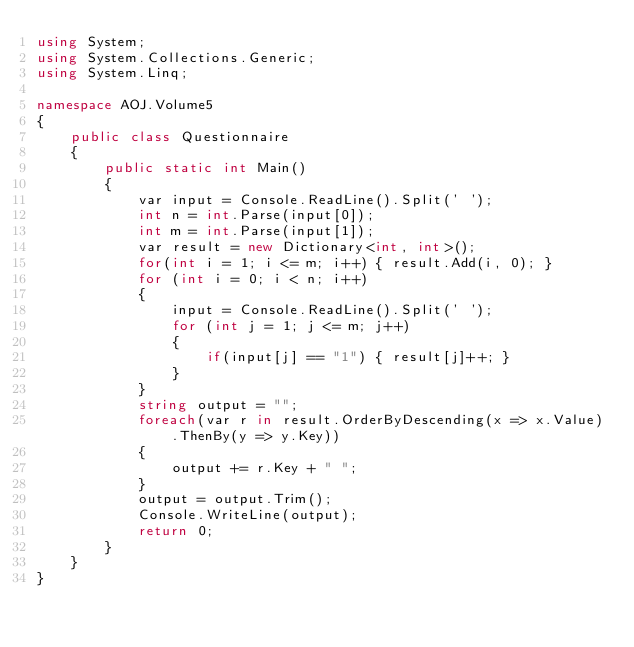<code> <loc_0><loc_0><loc_500><loc_500><_C#_>using System;
using System.Collections.Generic;
using System.Linq;

namespace AOJ.Volume5
{
    public class Questionnaire
    {
        public static int Main()
        {
            var input = Console.ReadLine().Split(' ');
            int n = int.Parse(input[0]);
            int m = int.Parse(input[1]);
            var result = new Dictionary<int, int>();
            for(int i = 1; i <= m; i++) { result.Add(i, 0); }
            for (int i = 0; i < n; i++)
            {
                input = Console.ReadLine().Split(' ');
                for (int j = 1; j <= m; j++)
                {
                    if(input[j] == "1") { result[j]++; }
                }
            }
            string output = "";
            foreach(var r in result.OrderByDescending(x => x.Value).ThenBy(y => y.Key))
            {
                output += r.Key + " ";
            }
            output = output.Trim();
            Console.WriteLine(output);
            return 0;
        }
    }
}</code> 